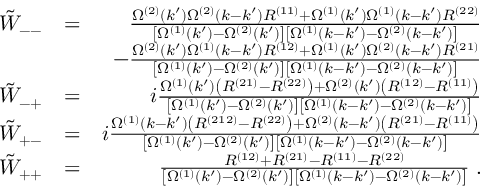Convert formula to latex. <formula><loc_0><loc_0><loc_500><loc_500>\begin{array} { r l r } { \tilde { W } _ { - - } } & { = } & { \frac { \Omega ^ { ( 2 ) } ( k ^ { \prime } ) \Omega ^ { ( 2 ) } ( k - k ^ { \prime } ) R ^ { ( 1 1 ) } + \Omega ^ { ( 1 ) } ( k ^ { \prime } ) \Omega ^ { ( 1 ) } ( k - k ^ { \prime } ) R ^ { ( 2 2 ) } } { \left [ \Omega ^ { ( 1 ) } ( k ^ { \prime } ) - \Omega ^ { ( 2 ) } ( k ^ { \prime } ) \right ] \left [ \Omega ^ { ( 1 ) } ( k - k ^ { \prime } ) - \Omega ^ { ( 2 ) } ( k - k ^ { \prime } ) \right ] } } \\ & { - \frac { \Omega ^ { ( 2 ) } ( k ^ { \prime } ) \Omega ^ { ( 1 ) } ( k - k ^ { \prime } ) R ^ { ( 1 2 ) } + \Omega ^ { ( 1 ) } ( k ^ { \prime } ) \Omega ^ { ( 2 ) } ( k - k ^ { \prime } ) R ^ { ( 2 1 ) } } { \left [ \Omega ^ { ( 1 ) } ( k ^ { \prime } ) - \Omega ^ { ( 2 ) } ( k ^ { \prime } ) \right ] \left [ \Omega ^ { ( 1 ) } ( k - k ^ { \prime } ) - \Omega ^ { ( 2 ) } ( k - k ^ { \prime } ) \right ] } } \\ { \tilde { W } _ { - + } } & { = } & { i \frac { \Omega ^ { ( 1 ) } ( k ^ { \prime } ) \left ( R ^ { ( 2 1 ) } - R ^ { ( 2 2 ) } \right ) + \Omega ^ { ( 2 ) } ( k ^ { \prime } ) \left ( R ^ { ( 1 2 ) } - R ^ { ( 1 1 ) } \right ) } { \left [ \Omega ^ { ( 1 ) } ( k ^ { \prime } ) - \Omega ^ { ( 2 ) } ( k ^ { \prime } ) \right ] \left [ \Omega ^ { ( 1 ) } ( k - k ^ { \prime } ) - \Omega ^ { ( 2 ) } ( k - k ^ { \prime } ) \right ] } } \\ { \tilde { W } _ { + - } } & { = } & { i \frac { \Omega ^ { ( 1 ) } ( k - k ^ { \prime } ) \left ( R ^ { ( 2 1 2 ) } - R ^ { ( 2 2 ) } \right ) + \Omega ^ { ( 2 ) } ( k - k ^ { \prime } ) \left ( R ^ { ( 2 1 ) } - R ^ { ( 1 1 ) } \right ) } { \left [ \Omega ^ { ( 1 ) } ( k ^ { \prime } ) - \Omega ^ { ( 2 ) } ( k ^ { \prime } ) \right ] \left [ \Omega ^ { ( 1 ) } ( k - k ^ { \prime } ) - \Omega ^ { ( 2 ) } ( k - k ^ { \prime } ) \right ] } } \\ { \tilde { W } _ { + + } } & { = } & { \frac { R ^ { ( 1 2 ) } + R ^ { ( 2 1 ) } - R ^ { ( 1 1 ) } - R ^ { ( 2 2 ) } } { \left [ \Omega ^ { ( 1 ) } ( k ^ { \prime } ) - \Omega ^ { ( 2 ) } ( k ^ { \prime } ) \right ] \left [ \Omega ^ { ( 1 ) } ( k - k ^ { \prime } ) - \Omega ^ { ( 2 ) } ( k - k ^ { \prime } ) \right ] } \, . } \end{array}</formula> 